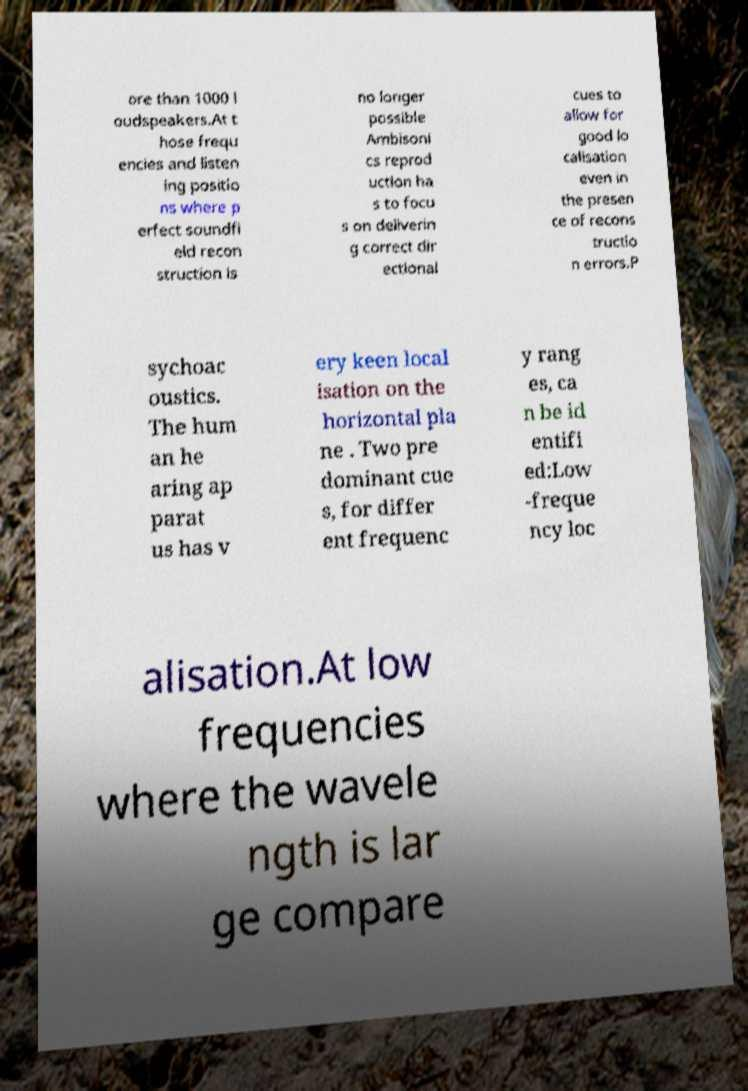Please read and relay the text visible in this image. What does it say? ore than 1000 l oudspeakers.At t hose frequ encies and listen ing positio ns where p erfect soundfi eld recon struction is no longer possible Ambisoni cs reprod uction ha s to focu s on deliverin g correct dir ectional cues to allow for good lo calisation even in the presen ce of recons tructio n errors.P sychoac oustics. The hum an he aring ap parat us has v ery keen local isation on the horizontal pla ne . Two pre dominant cue s, for differ ent frequenc y rang es, ca n be id entifi ed:Low -freque ncy loc alisation.At low frequencies where the wavele ngth is lar ge compare 